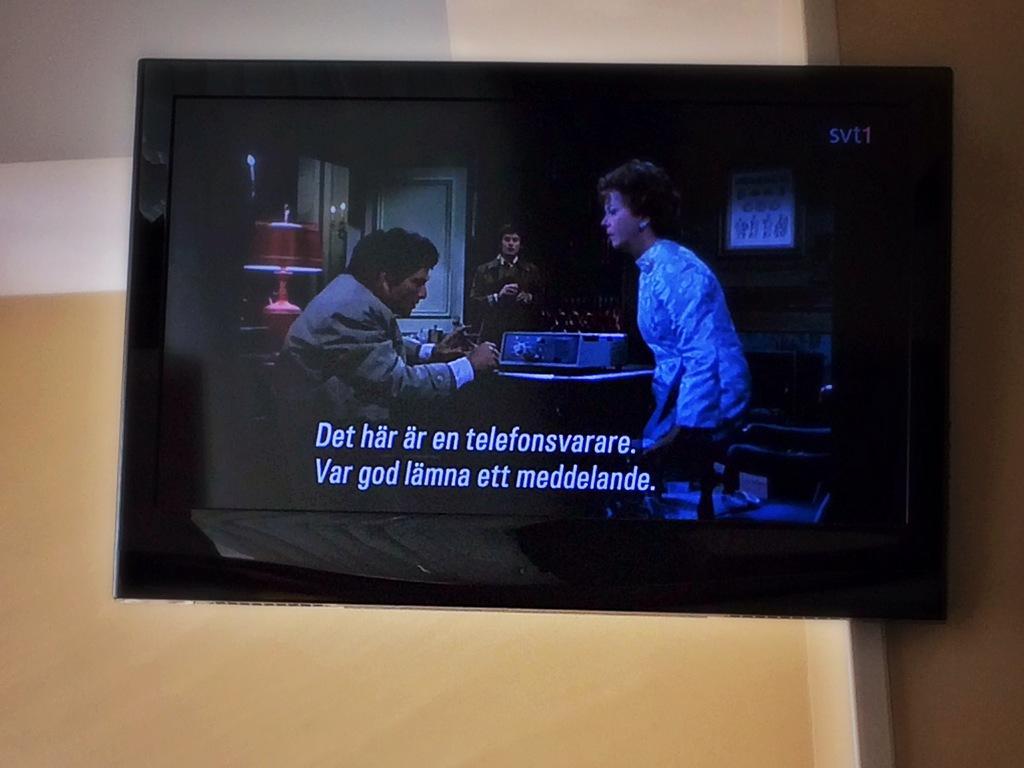Please provide a concise description of this image. In this image in the foreground there is a TV on the wall. 